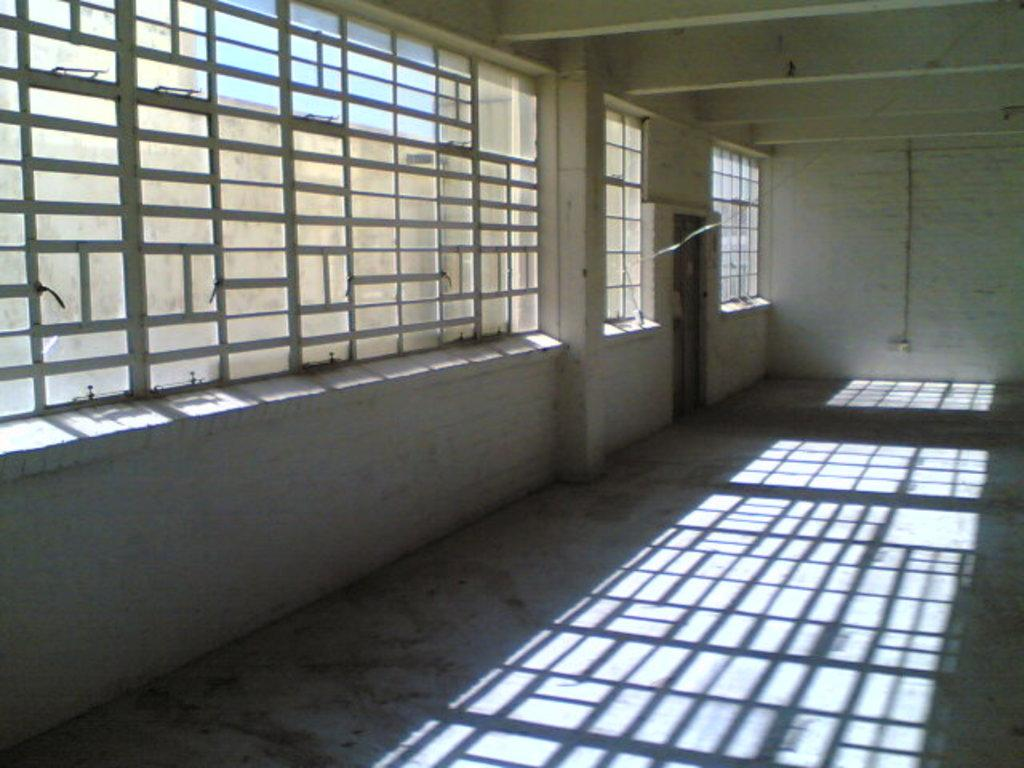What type of openings can be seen in the image? There are windows in the image. Is there any entrance or exit visible in the image? Yes, there is a door in the image. Where is the image taken? The image is taken in a room. What can be found on the wall in the image? There is a switch board attached to the wall in the image. What type of flooring can be seen in the image? The provided facts do not mention the flooring in the image, so we cannot determine the type of flooring. --- Facts: 1. There is a person sitting on a chair in the image. 2. The person is holding a book. 3. The book has a blue cover. 4. There is a table next to the chair. 5. There is a lamp on the table. Absurd Topics: ocean, bird, mountain Conversation: What is the person in the image doing? The person is sitting on a chair in the image. What is the person holding in the image? The person is holding a book in the image. What color is the book's cover? The book has a blue cover. What is located next to the chair in the image? There is a table next to the chair in the image. What object can be found on the table in the image? There is a lamp on the table in the image. Reasoning: Let's think step by step in order to produce the conversation. We start by identifying the main subject in the image, which is the person sitting on a chair. Then, we expand the conversation to include other items that are also visible, such as the book, the table, and the lamp. Each question is designed to elicit a specific detail about the image that is known from the provided facts. Absurd Question/Answer: Can you see any mountains in the background of the image? There is no mention of mountains in the provided facts, so we cannot determine if there are any mountains in the background of the image. 